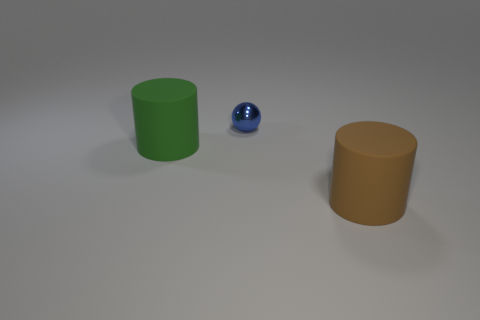There is a large object to the left of the big brown rubber cylinder; is it the same shape as the object behind the large green rubber cylinder?
Provide a short and direct response. No. What number of things are in front of the tiny metallic sphere and on the left side of the brown matte thing?
Offer a terse response. 1. Is there a matte cylinder of the same color as the tiny shiny sphere?
Your answer should be compact. No. What shape is the rubber object that is the same size as the brown matte cylinder?
Your response must be concise. Cylinder. There is a small metallic thing; are there any tiny metal spheres in front of it?
Ensure brevity in your answer.  No. Does the object that is right of the blue sphere have the same material as the cylinder that is on the left side of the sphere?
Your answer should be compact. Yes. How many rubber cylinders have the same size as the shiny sphere?
Your answer should be compact. 0. What is the large object that is to the left of the small blue shiny object made of?
Offer a very short reply. Rubber. What number of other large objects have the same shape as the big green thing?
Offer a very short reply. 1. What shape is the object that is made of the same material as the brown cylinder?
Give a very brief answer. Cylinder. 